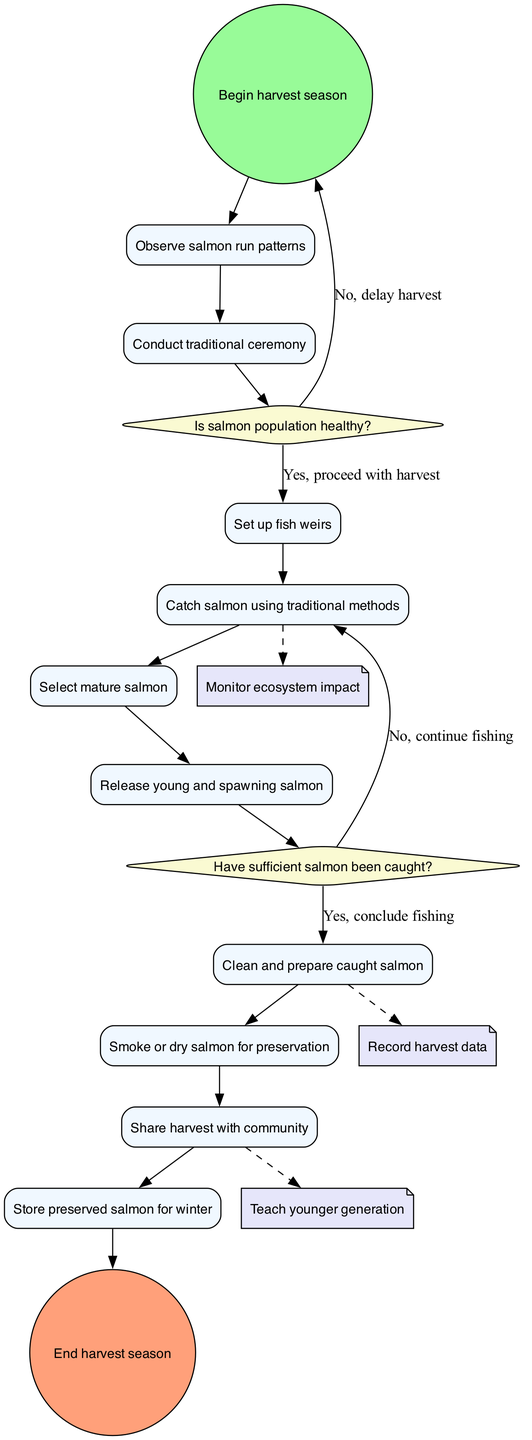What is the initial node of the diagram? The initial node is explicitly labeled as "Begin harvest season" in the diagram which indicates the starting point of the activity flow.
Answer: Begin harvest season How many activities are there in total? By counting the number of activities listed under the "activities" section, there are ten activities defined in the diagram.
Answer: 10 What decision point follows the activity "Conduct traditional ceremony"? The decision point that comes after "Conduct traditional ceremony" is "Is salmon population healthy?" which is directly connected from that activity.
Answer: Is salmon population healthy? What happens if the salmon population is not healthy? If the response to "Is salmon population healthy?" is "No," the flow directs back to the initial node, indicating the harvest is delayed.
Answer: Delay harvest Which activity involves the preservation of the caught salmon? The activity that involves preservation is "Smoke or dry salmon for preservation," as indicated in the flow of activities for preparing the caught salmon.
Answer: Smoke or dry salmon for preservation What is the final node of the diagram? The final node of the diagram is "End harvest season," which marks the completion of the harvesting process.
Answer: End harvest season What sustainability consideration is connected after catching salmon? The sustainability consideration connected after "Catch salmon using traditional methods" is "Monitor ecosystem impact," shown with a dashed edge indicating a non-sequential consideration.
Answer: Monitor ecosystem impact What must happen before concluding fishing? Before concluding fishing, the decision point "Have sufficient salmon been caught?" must be successfully evaluated, leading to the next action based on whether the answer is yes or no.
Answer: Have sufficient salmon been caught? Which activity involves community sharing of the harvest? The activity specifically denoting community involvement is "Share harvest with community," illustrating the communal aspect of the process.
Answer: Share harvest with community 